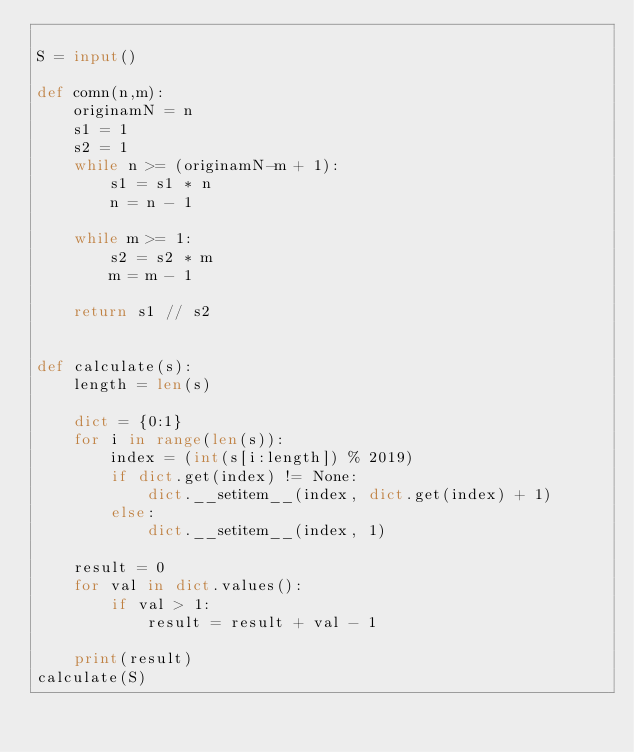<code> <loc_0><loc_0><loc_500><loc_500><_Python_>
S = input()

def comn(n,m):
    originamN = n
    s1 = 1
    s2 = 1
    while n >= (originamN-m + 1):
        s1 = s1 * n
        n = n - 1

    while m >= 1:
        s2 = s2 * m
        m = m - 1

    return s1 // s2


def calculate(s):
    length = len(s)

    dict = {0:1}
    for i in range(len(s)):
        index = (int(s[i:length]) % 2019)
        if dict.get(index) != None:
            dict.__setitem__(index, dict.get(index) + 1)
        else:
            dict.__setitem__(index, 1)

    result = 0
    for val in dict.values():
        if val > 1:
            result = result + val - 1

    print(result)
calculate(S)
</code> 